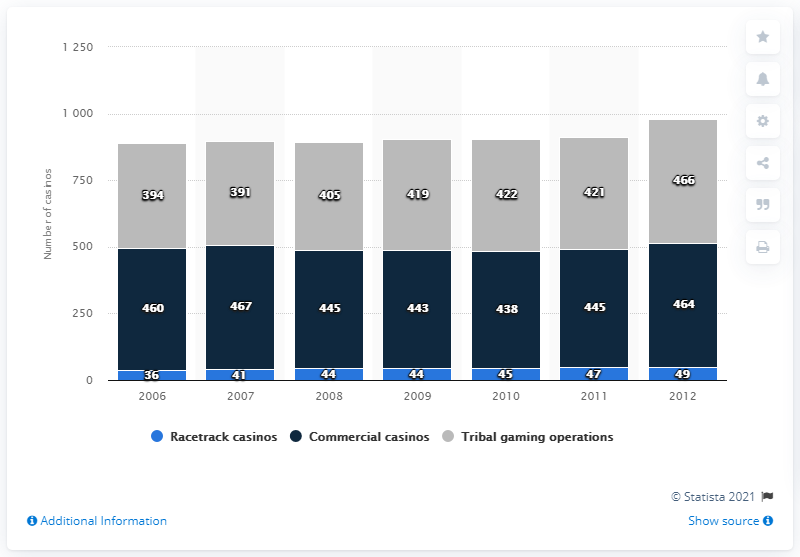Mention a couple of crucial points in this snapshot. In 2010, there were 438 commercial casinos in the United States. As of 2006, there were a total of 854 commercial and tribal casinos operating in the United States. In the year 2006, there were a total of 394 tribal casinos operating in the United States. 